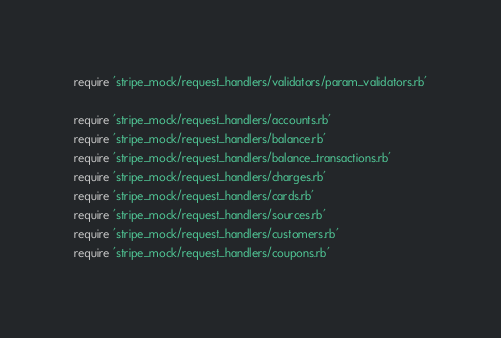<code> <loc_0><loc_0><loc_500><loc_500><_Ruby_>
require 'stripe_mock/request_handlers/validators/param_validators.rb'

require 'stripe_mock/request_handlers/accounts.rb'
require 'stripe_mock/request_handlers/balance.rb'
require 'stripe_mock/request_handlers/balance_transactions.rb'
require 'stripe_mock/request_handlers/charges.rb'
require 'stripe_mock/request_handlers/cards.rb'
require 'stripe_mock/request_handlers/sources.rb'
require 'stripe_mock/request_handlers/customers.rb'
require 'stripe_mock/request_handlers/coupons.rb'</code> 